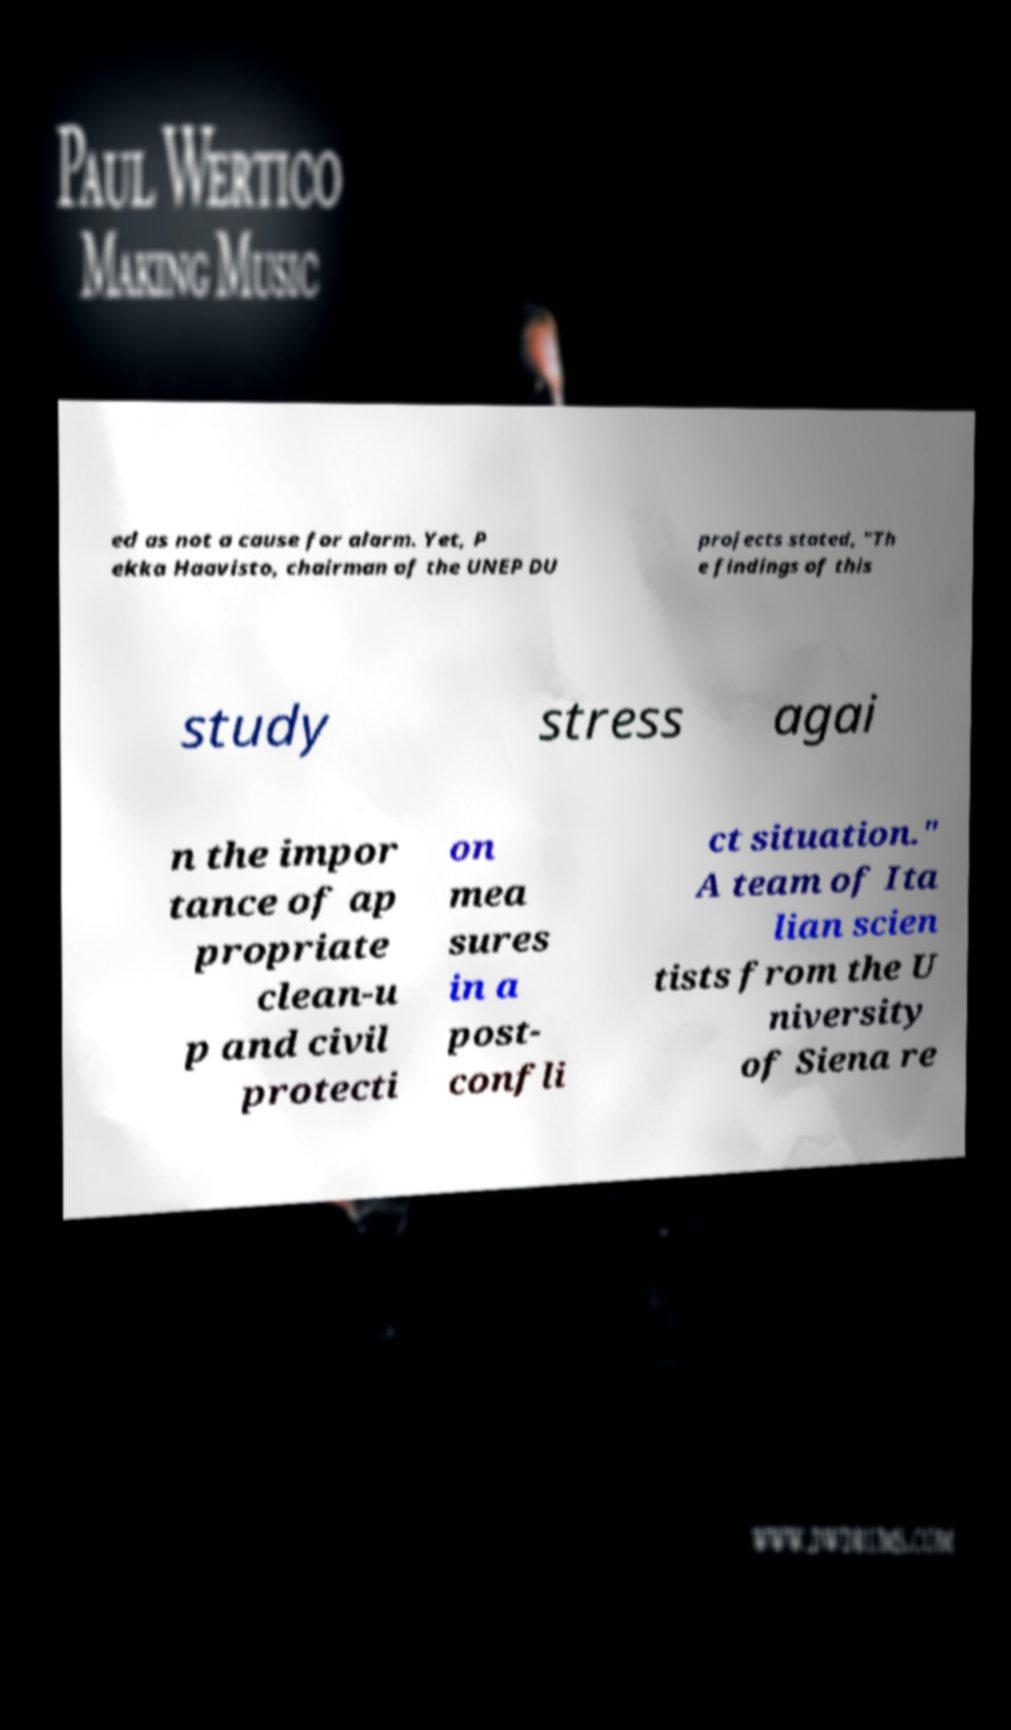Please read and relay the text visible in this image. What does it say? ed as not a cause for alarm. Yet, P ekka Haavisto, chairman of the UNEP DU projects stated, "Th e findings of this study stress agai n the impor tance of ap propriate clean-u p and civil protecti on mea sures in a post- confli ct situation." A team of Ita lian scien tists from the U niversity of Siena re 